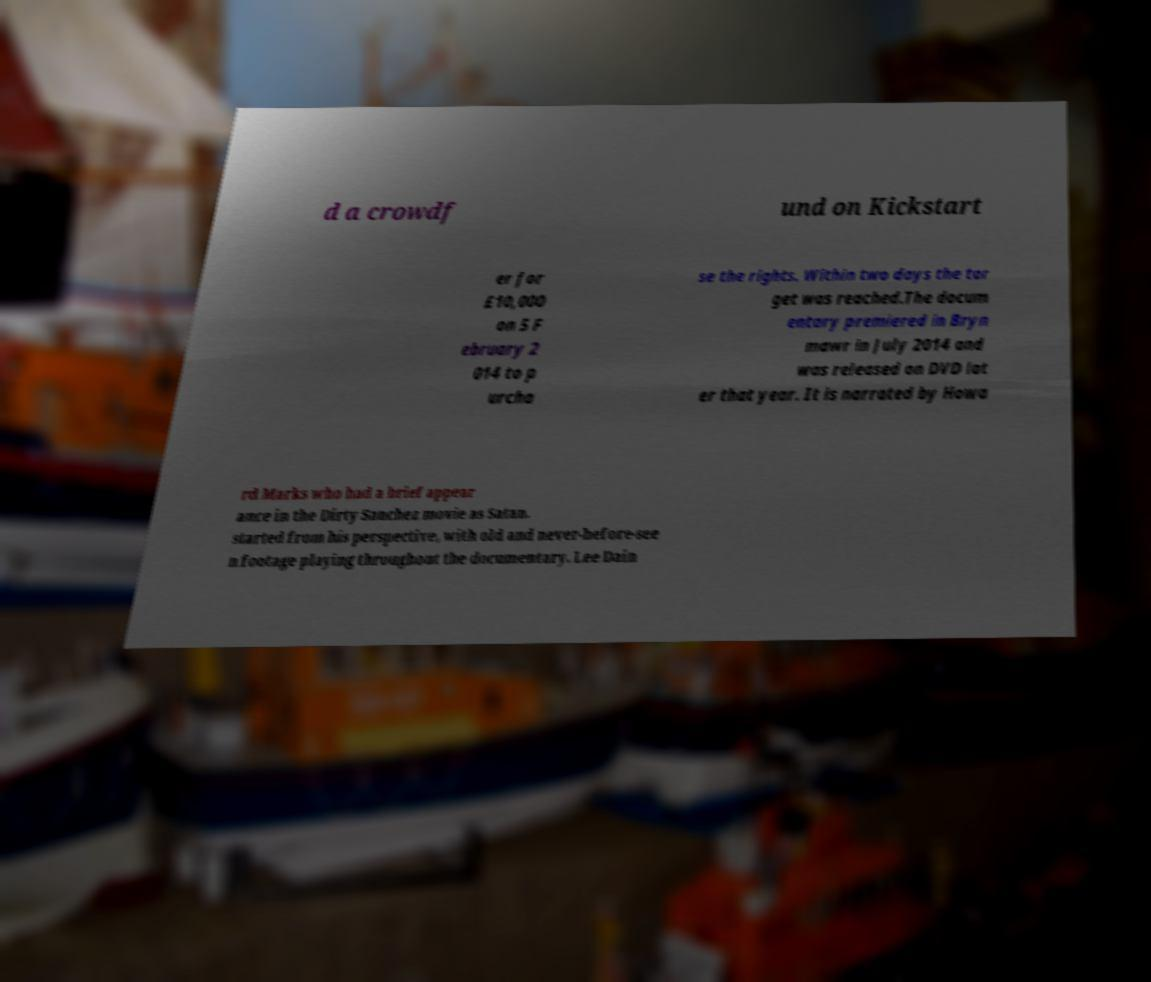Could you extract and type out the text from this image? d a crowdf und on Kickstart er for £10,000 on 5 F ebruary 2 014 to p urcha se the rights. Within two days the tar get was reached.The docum entary premiered in Bryn mawr in July 2014 and was released on DVD lat er that year. It is narrated by Howa rd Marks who had a brief appear ance in the Dirty Sanchez movie as Satan. started from his perspective, with old and never-before-see n footage playing throughout the documentary. Lee Dain 